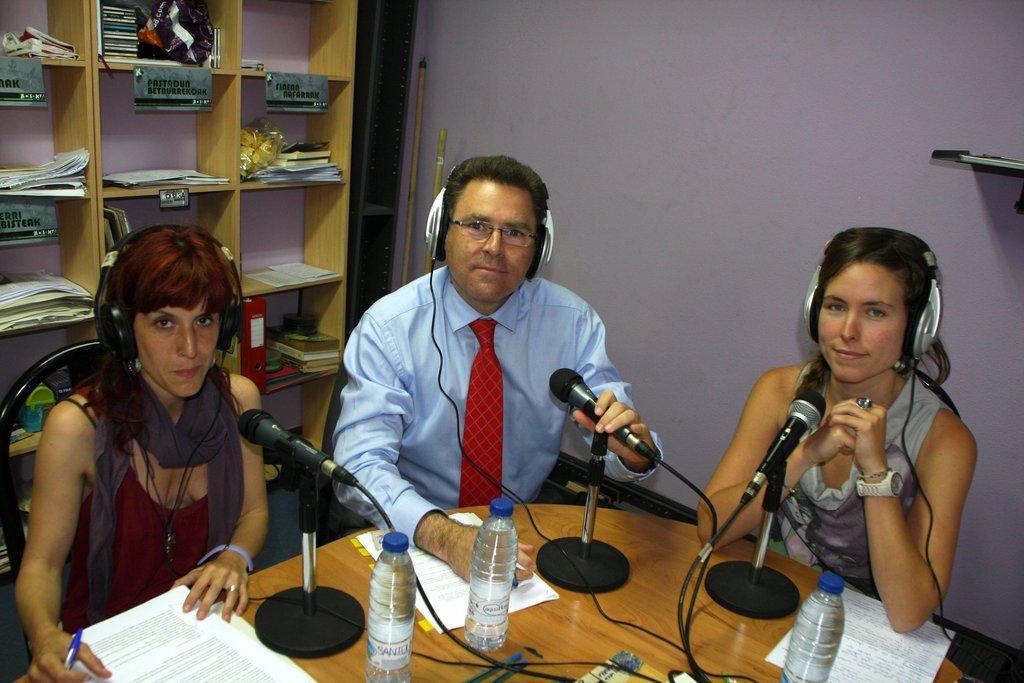In one or two sentences, can you explain what this image depicts? In the picture we can see a three people sitting on a chairs, two are women and one is man, they are sitting near to the table, on the table we can find a microphones placed on the stand, two bottles, and papers, in the background we can see racks and some papers are placed in the racks and a wall and two sticks placed near the wall. 